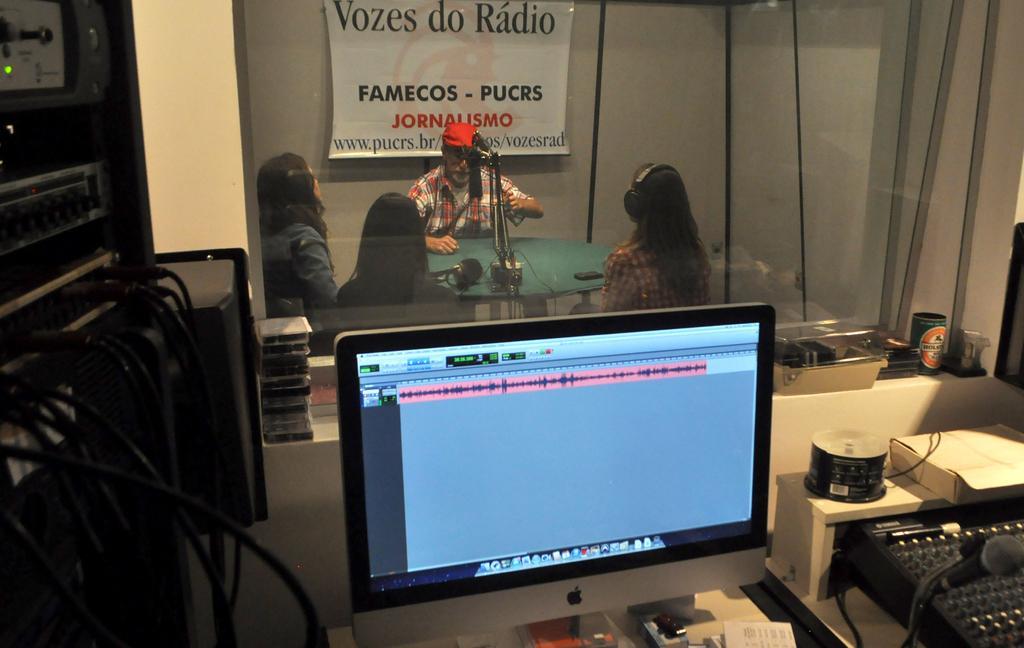In one or two sentences, can you explain what this image depicts? This picture is clicked inside. In the foreground there is table on the top of which a keyboard, boxes, monitor and some other items are placed. On the left corner there is an electronic device and some cables. In the center we can see the group of people seems to be sitting on the chairs and there is a table on the top of which some items are placed. In the background we can see a wall and a poster hanging on the wall on which the text is printed. 